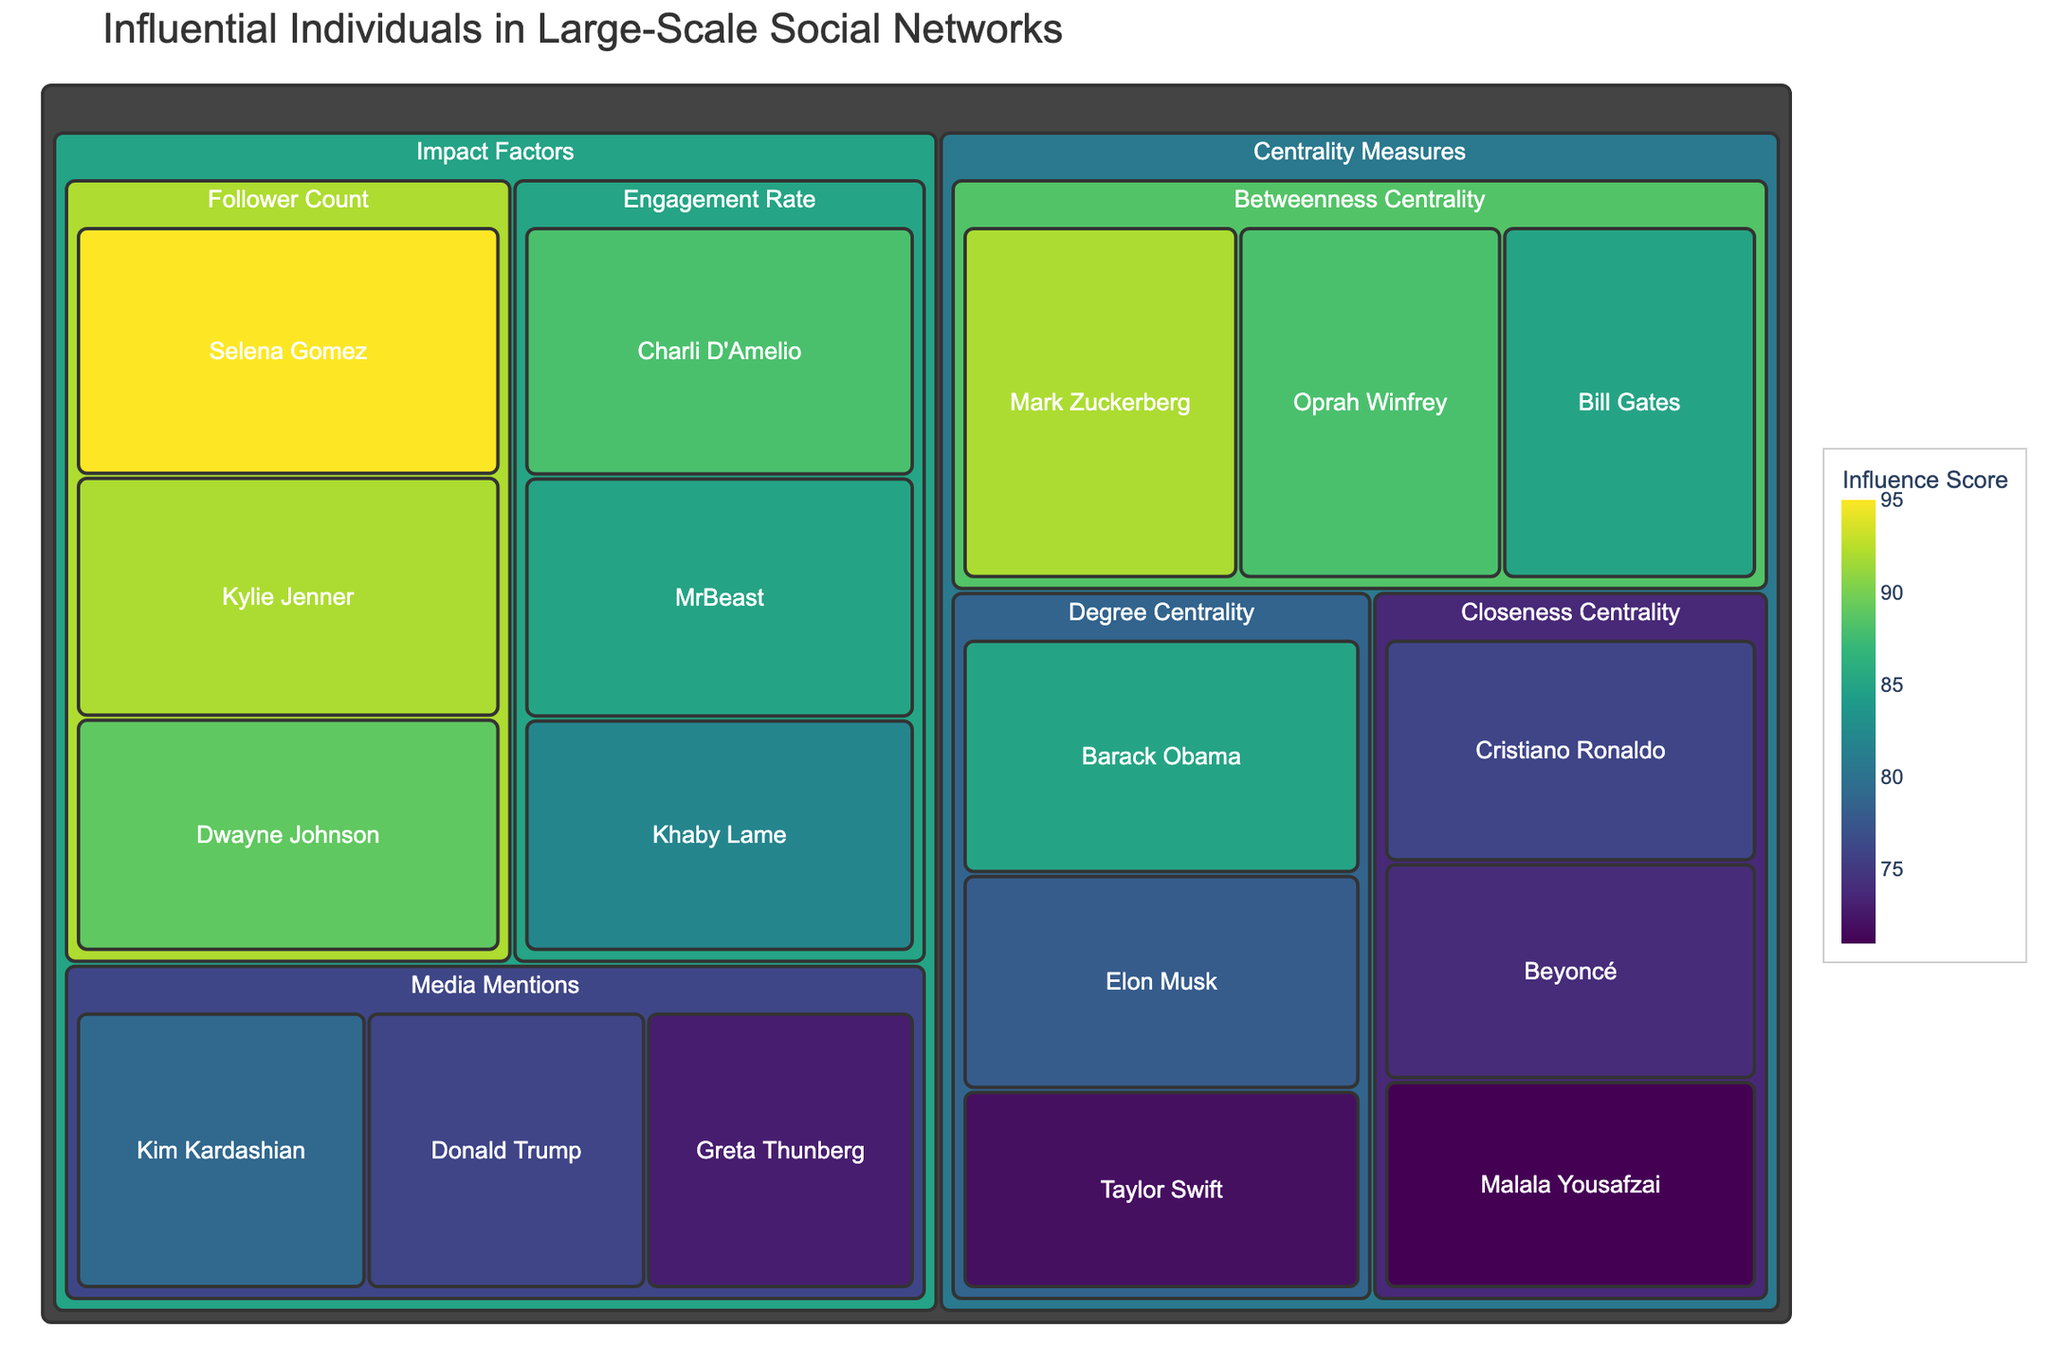What is the title of the treemap? The title of the treemap is typically displayed at the top of the figure. It helps users understand the central theme or focus of the visualization.
Answer: Influential Individuals in Large-Scale Social Networks How many categories are there in the treemap? The categories in a treemap are typically distinguished by different sections or colors. By counting them, we can determine the total number of categories.
Answer: 2 (Centrality Measures, Impact Factors) Who has the highest Betweenness Centrality score? To find out who has the highest Betweenness Centrality score, look at the subcategory "Betweenness Centrality" and identify the individual with the highest value.
Answer: Mark Zuckerberg What is the total influence score for Degree Centrality? Sum the values of the influence scores for all individuals listed under the Degree Centrality subcategory.
Answer: 85 + 78 + 72 = 235 Which centrality measure has the highest average value, and what is that value? To find the average value for each centrality measure, sum the individual influence scores for each measure and divide by the number of individuals in that measure. Compare the averages. For Degree Centrality: (85 + 78 + 72)/3 = 78.33. For Betweenness Centrality: (92 + 88 + 85)/3 = 88.33. For Closeness Centrality: (76 + 74 + 71)/3 = 73.67. Betweenness Centrality has the highest average value.
Answer: Betweenness Centrality, 88.33 What is the combined influence score for Follower Count and Engagement Rate in the Impact Factors category? Add the total influence scores of individuals in "Follower Count" and "Engagement Rate". Follower Count: (95 + 92 + 89) = 276. Engagement Rate: (88 + 85 + 82) = 255. Combined: 276 + 255 = 531.
Answer: 531 Who has a higher Media Mentions score, Kim Kardashian or Donald Trump? Compare the values of Media Mentions score for Kim Kardashian and Donald Trump. Kim Kardashian has 79, and Donald Trump has 76.
Answer: Kim Kardashian What is the difference in influence score between Cristiano Ronaldo and Malala Yousafzai in Closeness Centrality? Subtract Malala Yousafzai's influence score from Cristiano Ronaldo's in Closeness Centrality. 76 - 71 = 5.
Answer: 5 Based on the color intensity, which individual appears to have the highest overall score in the Impact Factors category? In a treemap, color intensity is used to represent the value of the influence scores. The color with the highest intensity in the Impact Factors category indicates the highest score.
Answer: Selena Gomez Which category, Centrality Measures or Impact Factors, has the largest total influence score? Sum the total influence scores for all individuals in each category and compare the sums. Centrality Measures: (85 + 78 + 72 + 92 + 88 + 85 + 76 + 74 + 71) = 721. Impact Factors: (95 + 92 + 89 + 88 + 85 + 82 + 79 + 76 + 73) = 759. Impact Factors has the larger total.
Answer: Impact Factors 